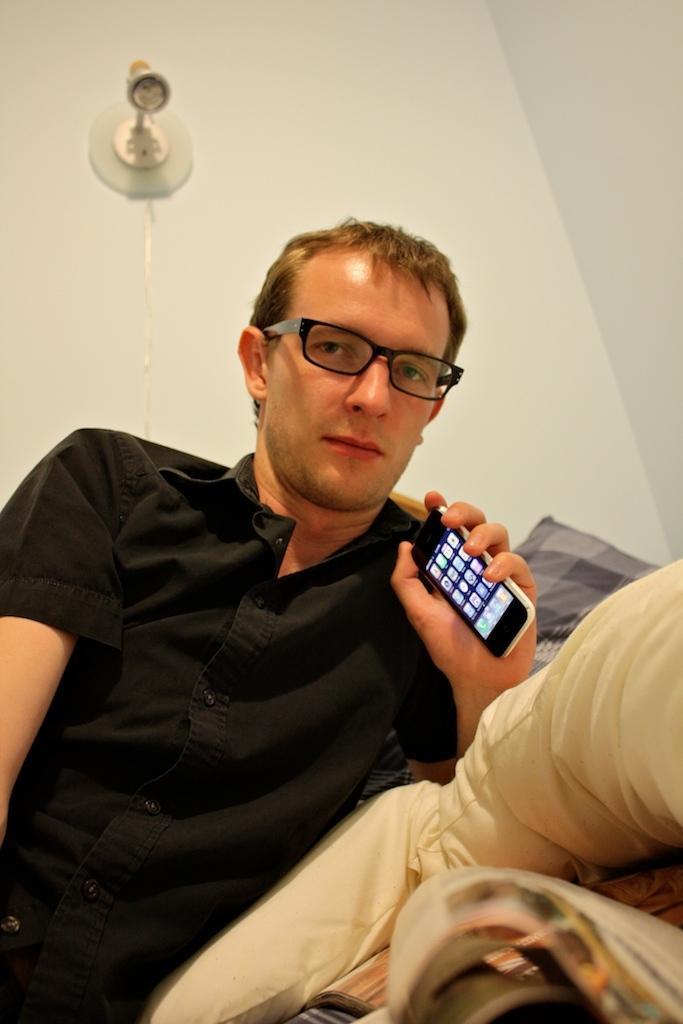Describe this image in one or two sentences. In this picture we can see man wore black color shirt, spectacle holding mobile in his hand and beside to him we can see pillow on bed and in background we can see wall, light. 